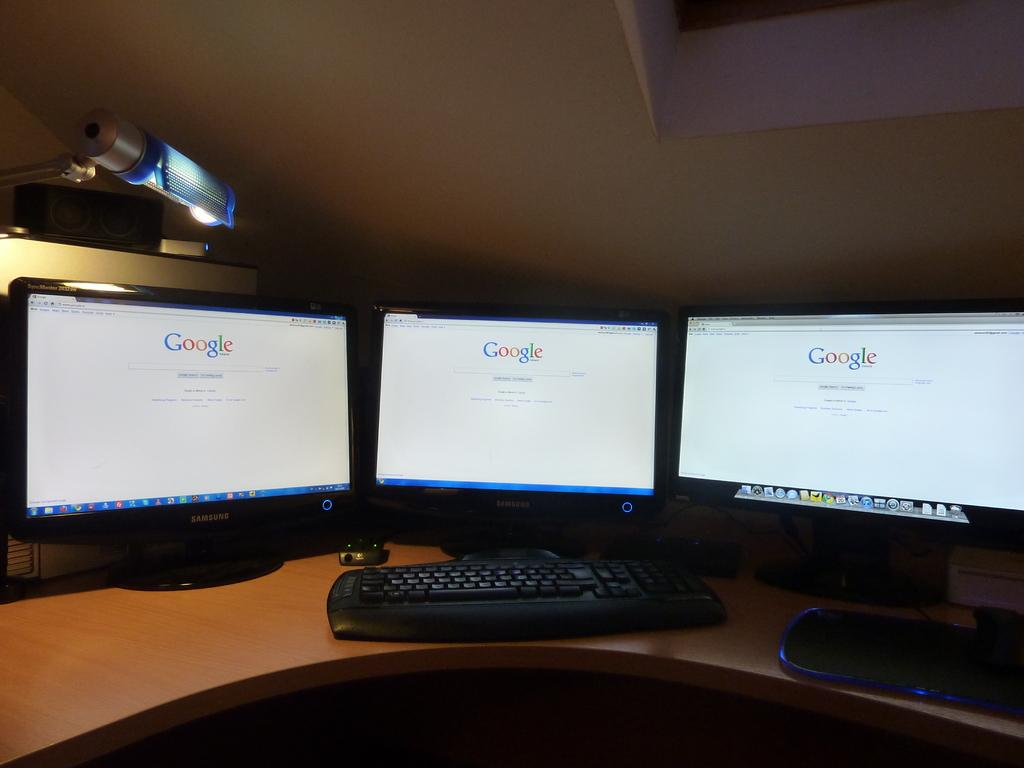<image>
Relay a brief, clear account of the picture shown. Three monitors are positioned to the center all with Google loaded on the screen 